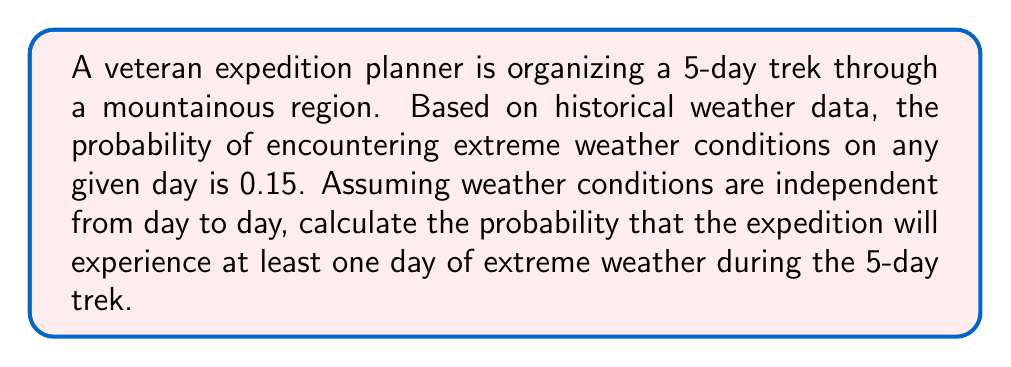Can you solve this math problem? Let's approach this step-by-step:

1) First, let's define our events:
   Let A be the event of experiencing at least one day of extreme weather.
   Let B be the event of not experiencing any extreme weather.

2) We're looking for P(A), but it's easier to calculate P(B) and then use the complement rule.

3) To have no extreme weather, each day must not have extreme weather:
   P(B) = P(no extreme weather on day 1 AND day 2 AND day 3 AND day 4 AND day 5)

4) Since the days are independent, we can multiply the probabilities:
   P(B) = P(no extreme weather on one day)^5

5) The probability of no extreme weather on one day is the complement of extreme weather:
   P(no extreme weather on one day) = 1 - 0.15 = 0.85

6) Now we can calculate P(B):
   P(B) = 0.85^5 ≈ 0.4437

7) Finally, we use the complement rule to find P(A):
   P(A) = 1 - P(B) = 1 - 0.4437 ≈ 0.5563

Therefore, the probability of experiencing at least one day of extreme weather is approximately 0.5563 or 55.63%.

We can express this mathematically as:

$$P(A) = 1 - (1 - p)^n$$

Where:
$p$ = probability of extreme weather on one day = 0.15
$n$ = number of days = 5

$$P(A) = 1 - (1 - 0.15)^5 ≈ 0.5563$$
Answer: The probability of experiencing at least one day of extreme weather during the 5-day expedition is approximately 0.5563 or 55.63%. 